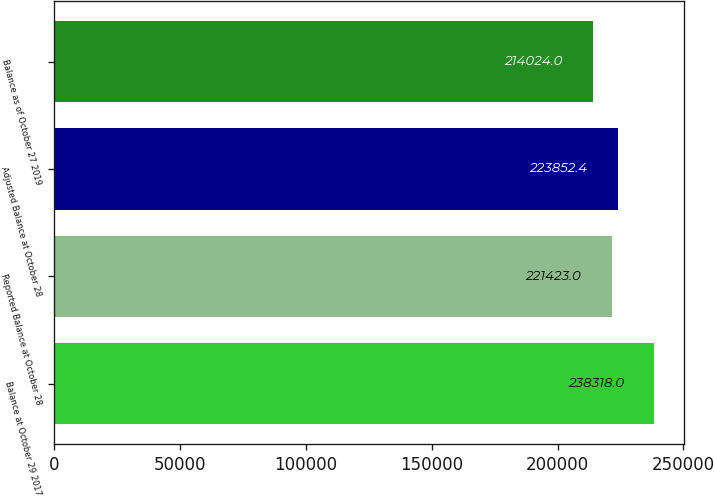Convert chart to OTSL. <chart><loc_0><loc_0><loc_500><loc_500><bar_chart><fcel>Balance at October 29 2017<fcel>Reported Balance at October 28<fcel>Adjusted Balance at October 28<fcel>Balance as of October 27 2019<nl><fcel>238318<fcel>221423<fcel>223852<fcel>214024<nl></chart> 